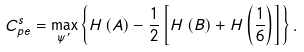<formula> <loc_0><loc_0><loc_500><loc_500>C _ { p e } ^ { s } = \max _ { \psi ^ { \prime } } \left \{ H \left ( A \right ) - \frac { 1 } { 2 } \left [ H \left ( B \right ) + H \left ( \frac { 1 } { 6 } \right ) \right ] \right \} .</formula> 